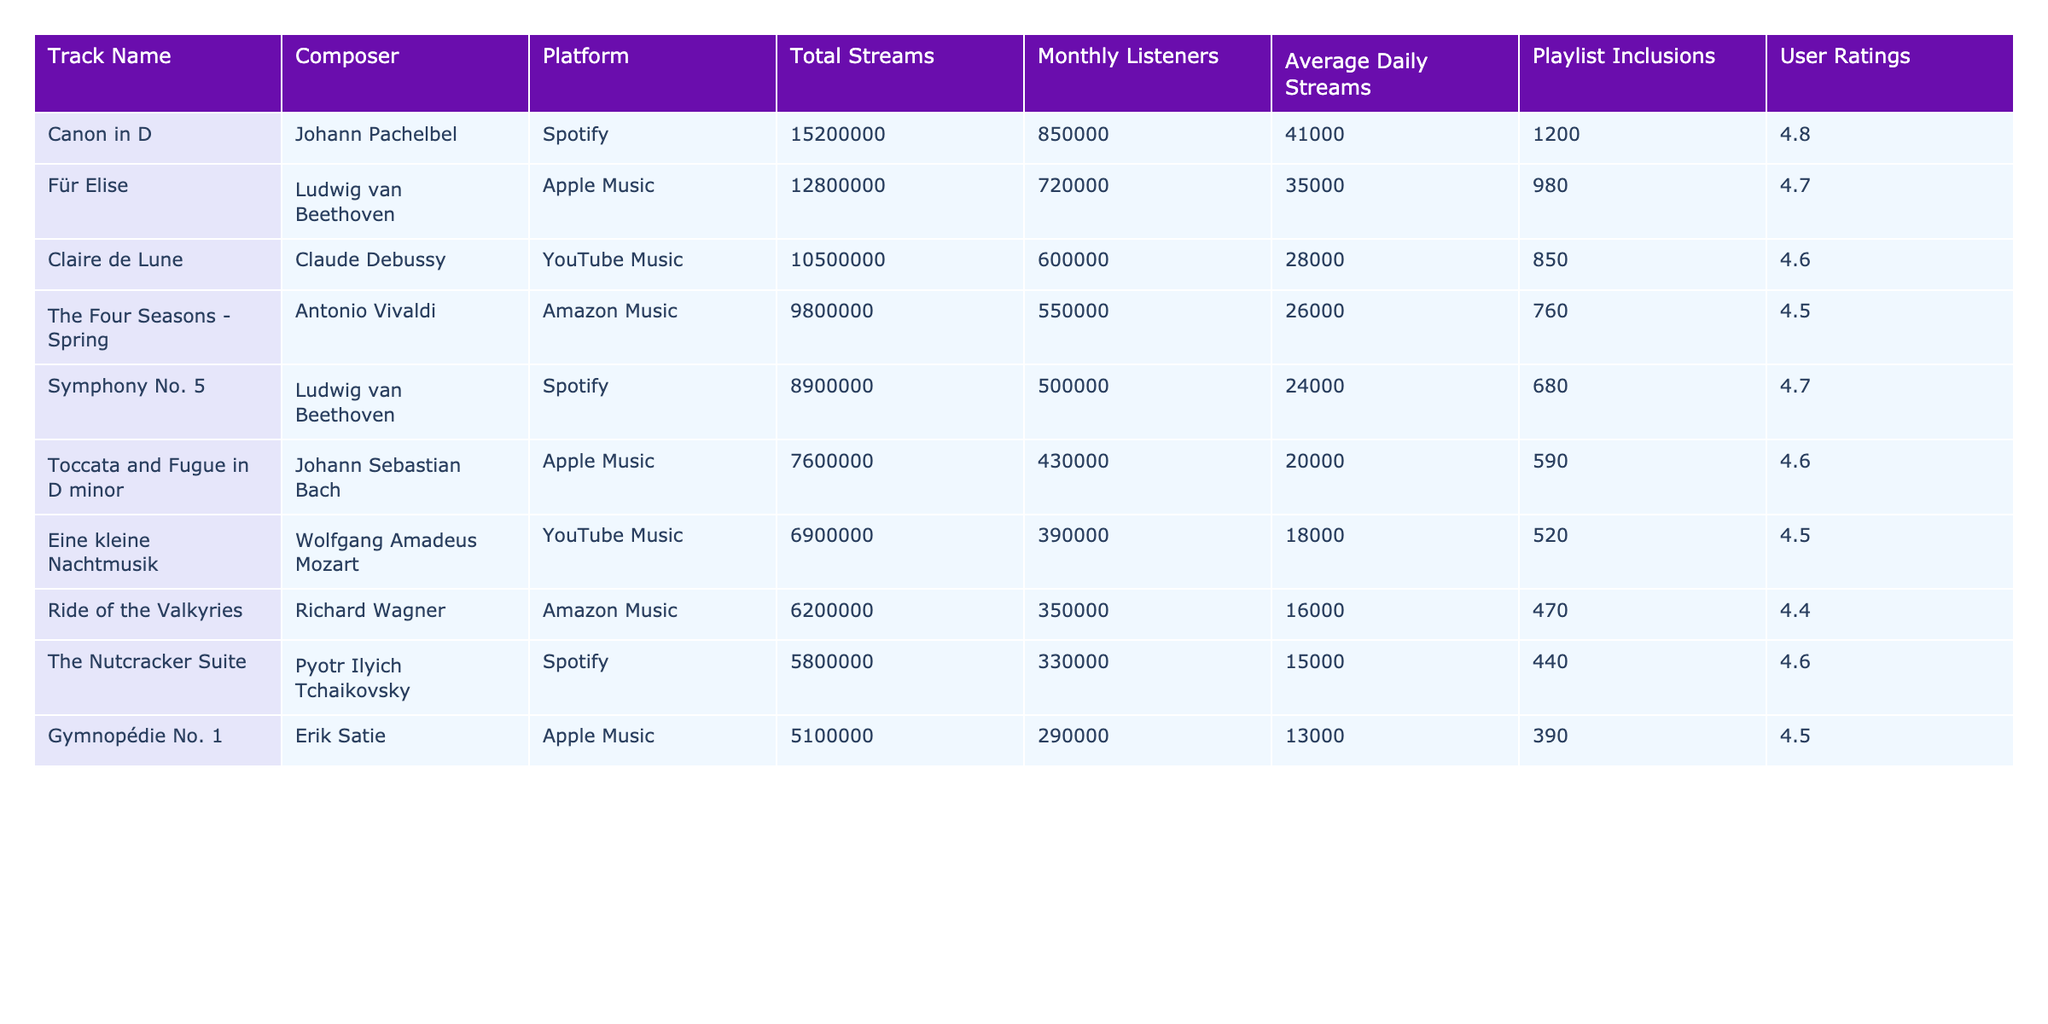What is the total number of streams for "Für Elise"? The table shows that "Für Elise" has a total of 12,800,000 streams listed under the "Total Streams" column.
Answer: 12,800,000 Which classical track has the highest user rating? The table indicates that "Canon in D" has the highest user rating of 4.8 in the "User Ratings" column.
Answer: Canon in D How many more monthly listeners does "Symphony No. 5" have than "Toccata and Fugue in D minor"? "Symphony No. 5" has 500,000 monthly listeners, while "Toccata and Fugue in D minor" has 430,000. The difference is 500,000 - 430,000 = 70,000.
Answer: 70,000 What is the average total streams of tracks composed by Ludwig van Beethoven? "Symphony No. 5" has 8,900,000 streams and "Für Elise" has 12,800,000 streams. The average is (8,900,000 + 12,800,000) / 2 = 10,850,000.
Answer: 10,850,000 Which platform has the least total streams listed in the table? The table shows that "Ride of the Valkyries" on Amazon Music has the least total streams at 6,200,000.
Answer: Amazon Music Is "The Nutcracker Suite" included in more playlists than "Eine kleine Nachtmusik"? "The Nutcracker Suite" has 440 playlist inclusions while "Eine kleine Nachtmusik" has 520; therefore, "The Nutcracker Suite" is included in fewer playlists.
Answer: No What is the total number of playlist inclusions for all tracks combined? Adding all the playlist inclusions: 1200 + 980 + 850 + 760 + 680 + 590 + 520 + 470 + 440 + 390 = 6,570.
Answer: 6,570 Which track has an average daily streams higher than "Gymnopédie No. 1"? "The Nutcracker Suite" has an average daily stream of 15,000, which is higher than "Gymnopédie No. 1" with 13,000.
Answer: The Nutcracker Suite What is the percentage of total streams for "Claire de Lune" compared to the total streams of all tracks combined? The total streams for "Claire de Lune" is 10,500,000. Adding all streams gives a total of 59,300,000. The percentage is (10,500,000 / 59,300,000) * 100 ≈ 17.7%.
Answer: 17.7% How many classical tracks have a total stream count above 10 million? By reviewing the total streams, tracks with streams above 10 million are: "Canon in D," "Für Elise," and "Claire de Lune," making it three tracks.
Answer: 3 